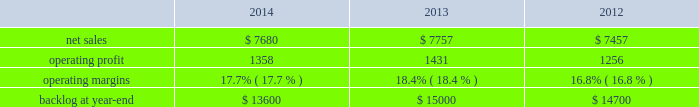Is&gs 2019 operating profit decreased $ 60 million , or 8% ( 8 % ) , for 2014 compared to 2013 .
The decrease was primarily attributable to the activities mentioned above for sales , lower risk retirements and reserves recorded on an international program , partially offset by severance recoveries related to the restructuring announced in november 2013 of approximately $ 20 million for 2014 .
Adjustments not related to volume , including net profit booking rate adjustments , were approximately $ 30 million lower for 2014 compared to 2013 .
2013 compared to 2012 is&gs 2019 net sales decreased $ 479 million , or 5% ( 5 % ) , for 2013 compared to 2012 .
The decrease was attributable to lower net sales of about $ 495 million due to decreased volume on various programs ( command and control programs for classified customers , ngi and eram programs ) ; and approximately $ 320 million due to the completion of certain programs ( such as total information processing support services , the transportation worker identification credential and the outsourcing desktop initiative for nasa ) .
The decrease was partially offset by higher net sales of about $ 340 million due to the start-up of certain programs ( such as the disa gsm-o and the national science foundation antarctic support ) .
Is&gs 2019 operating profit decreased $ 49 million , or 6% ( 6 % ) , for 2013 compared to 2012 .
The decrease was primarily attributable to lower operating profit of about $ 55 million due to certain programs nearing the end of their life cycles , partially offset by higher operating profit of approximately $ 15 million due to the start-up of certain programs .
Adjustments not related to volume , including net profit booking rate adjustments and other matters , were comparable for 2013 compared to 2012 .
Backlog backlog increased in 2014 compared to 2013 primarily due to several multi-year international awards and various u.s .
Multi-year extensions .
This increase was partially offset by declining activities on various direct warfighter support and command and control programs impacted by defense budget reductions .
Backlog decreased in 2013 compared to 2012 primarily due to lower orders on several programs ( such as eram and ngi ) , higher sales on certain programs ( the national science foundation antarctic support and the disa gsm-o ) and declining activities on several smaller programs primarily due to the continued downturn in federal information technology budgets .
Trends we expect is&gs 2019 net sales to decline in 2015 in the low to mid single digit percentage range as compared to 2014 , primarily driven by the continued downturn in federal information technology budgets , an increasingly competitive environment , including the disaggregation of existing contracts , and new contract award delays , partially offset by increased sales resulting from acquisitions that occurred during the year .
Operating profit is expected to decline in the low double digit percentage range in 2015 primarily driven by volume and an increase in intangible amortization from 2014 acquisition activity , resulting in 2015 margins that are lower than 2014 results .
Missiles and fire control our mfc business segment provides air and missile defense systems ; tactical missiles and air-to-ground precision strike weapon systems ; logistics and other technical services ; fire control systems ; mission operations support , readiness , engineering support and integration services ; and manned and unmanned ground vehicles .
Mfc 2019s major programs include pac-3 , thaad , multiple launch rocket system , hellfire , jassm , javelin , apache , sniper ae , low altitude navigation and targeting infrared for night ( lantirn ae ) and sof clss .
Mfc 2019s operating results included the following ( in millions ) : .
2014 compared to 2013 mfc 2019s net sales for 2014 decreased $ 77 million , or 1% ( 1 % ) , compared to 2013 .
The decrease was primarily attributable to lower net sales of approximately $ 385 million for technical services programs due to decreased volume reflecting market pressures ; and about $ 115 million for tactical missile programs due to fewer deliveries ( primarily high mobility artillery .
What was the percentage change in the net sales from 2012 to 2013? 
Computations: ((7757 - 7457) / 7457)
Answer: 0.04023. 